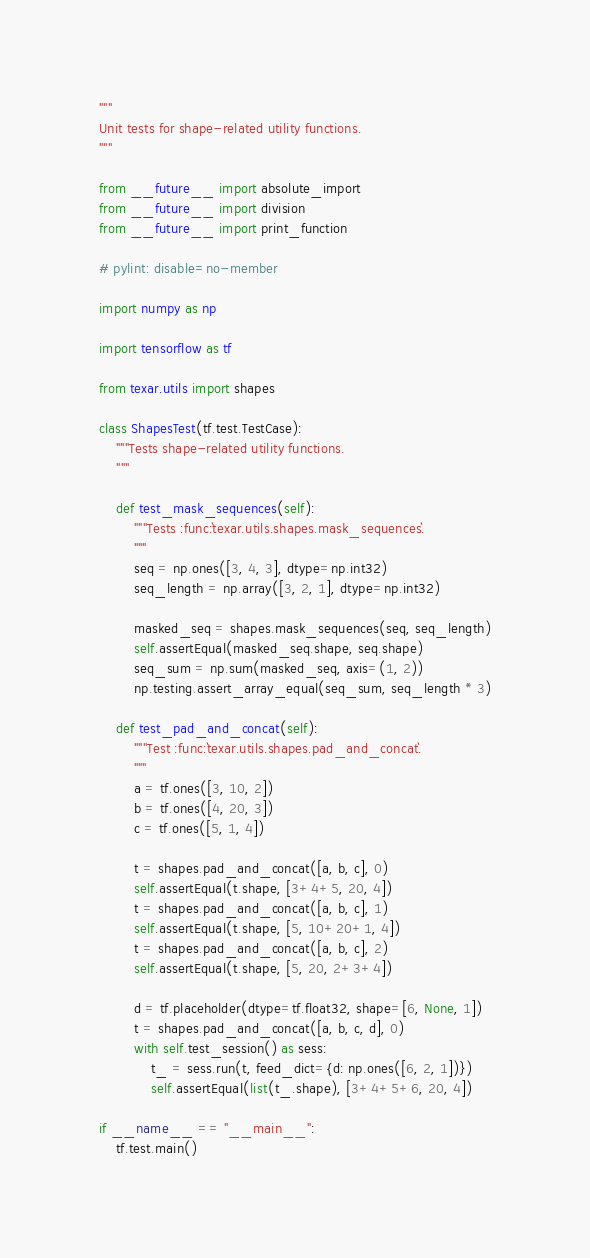Convert code to text. <code><loc_0><loc_0><loc_500><loc_500><_Python_>"""
Unit tests for shape-related utility functions.
"""

from __future__ import absolute_import
from __future__ import division
from __future__ import print_function

# pylint: disable=no-member

import numpy as np

import tensorflow as tf

from texar.utils import shapes

class ShapesTest(tf.test.TestCase):
    """Tests shape-related utility functions.
    """

    def test_mask_sequences(self):
        """Tests :func:`texar.utils.shapes.mask_sequences`.
        """
        seq = np.ones([3, 4, 3], dtype=np.int32)
        seq_length = np.array([3, 2, 1], dtype=np.int32)

        masked_seq = shapes.mask_sequences(seq, seq_length)
        self.assertEqual(masked_seq.shape, seq.shape)
        seq_sum = np.sum(masked_seq, axis=(1, 2))
        np.testing.assert_array_equal(seq_sum, seq_length * 3)

    def test_pad_and_concat(self):
        """Test :func:`texar.utils.shapes.pad_and_concat`.
        """
        a = tf.ones([3, 10, 2])
        b = tf.ones([4, 20, 3])
        c = tf.ones([5, 1, 4])

        t = shapes.pad_and_concat([a, b, c], 0)
        self.assertEqual(t.shape, [3+4+5, 20, 4])
        t = shapes.pad_and_concat([a, b, c], 1)
        self.assertEqual(t.shape, [5, 10+20+1, 4])
        t = shapes.pad_and_concat([a, b, c], 2)
        self.assertEqual(t.shape, [5, 20, 2+3+4])

        d = tf.placeholder(dtype=tf.float32, shape=[6, None, 1])
        t = shapes.pad_and_concat([a, b, c, d], 0)
        with self.test_session() as sess:
            t_ = sess.run(t, feed_dict={d: np.ones([6, 2, 1])})
            self.assertEqual(list(t_.shape), [3+4+5+6, 20, 4])

if __name__ == "__main__":
    tf.test.main()

</code> 